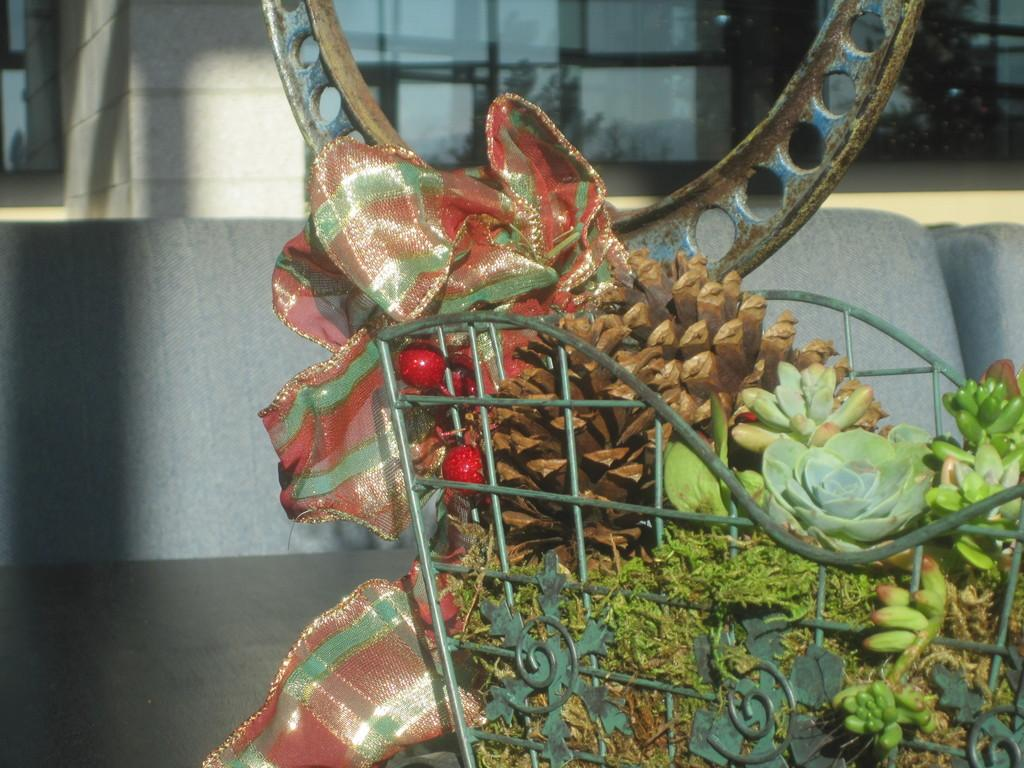What object is present in the image that can hold items? There is a basket in the image. What is inside the basket? The basket contains flowers and plants. What is located next to the basket? There is a cloth to the side of the basket. What type of jam is being served on the cloth next to the basket? There is no jam present in the image; the cloth is simply located next to the basket. 